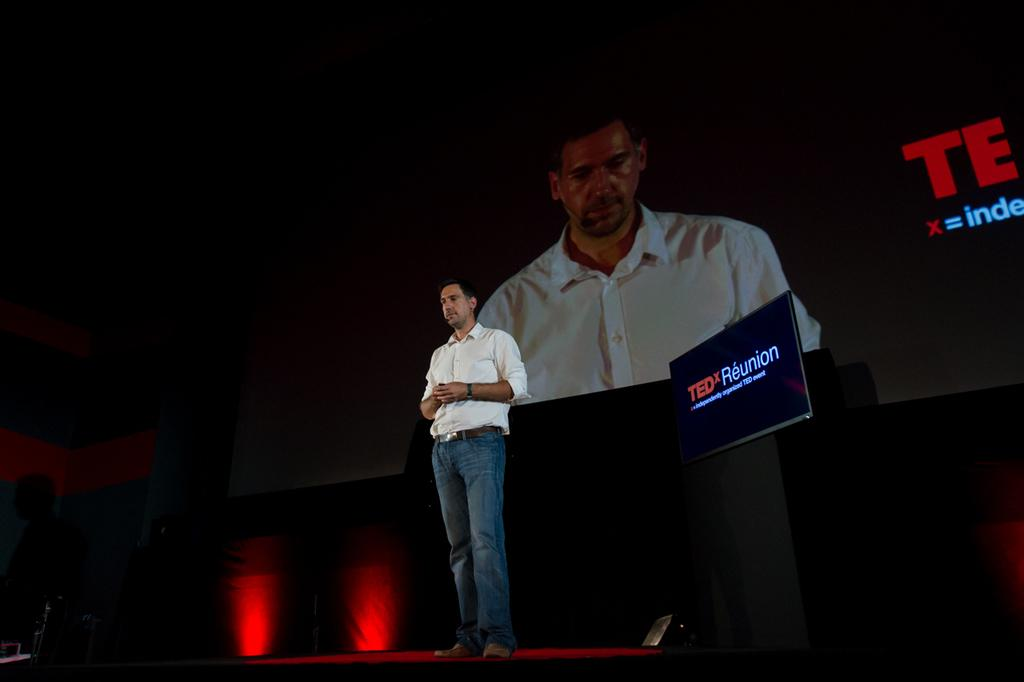What is the person in the image doing? The person is standing on the stage. How is the person's image being projected? The person is also visible on the projector. What is present on the floor in the image? There is a stand and a light on the floor. What type of pin can be seen floating in space in the image? There is no mention of a pin or space in the image, so it cannot be determined if a pin is floating in space. 